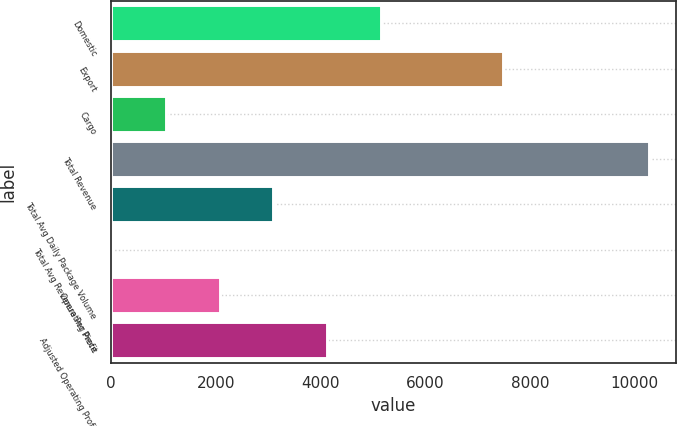Convert chart to OTSL. <chart><loc_0><loc_0><loc_500><loc_500><bar_chart><fcel>Domestic<fcel>Export<fcel>Cargo<fcel>Total Revenue<fcel>Total Avg Daily Package Volume<fcel>Total Avg Revenue Per Piece<fcel>Operating Profit<fcel>Adjusted Operating Profit<nl><fcel>5150.61<fcel>7488<fcel>1046.33<fcel>10281<fcel>3098.47<fcel>20.26<fcel>2072.4<fcel>4124.54<nl></chart> 